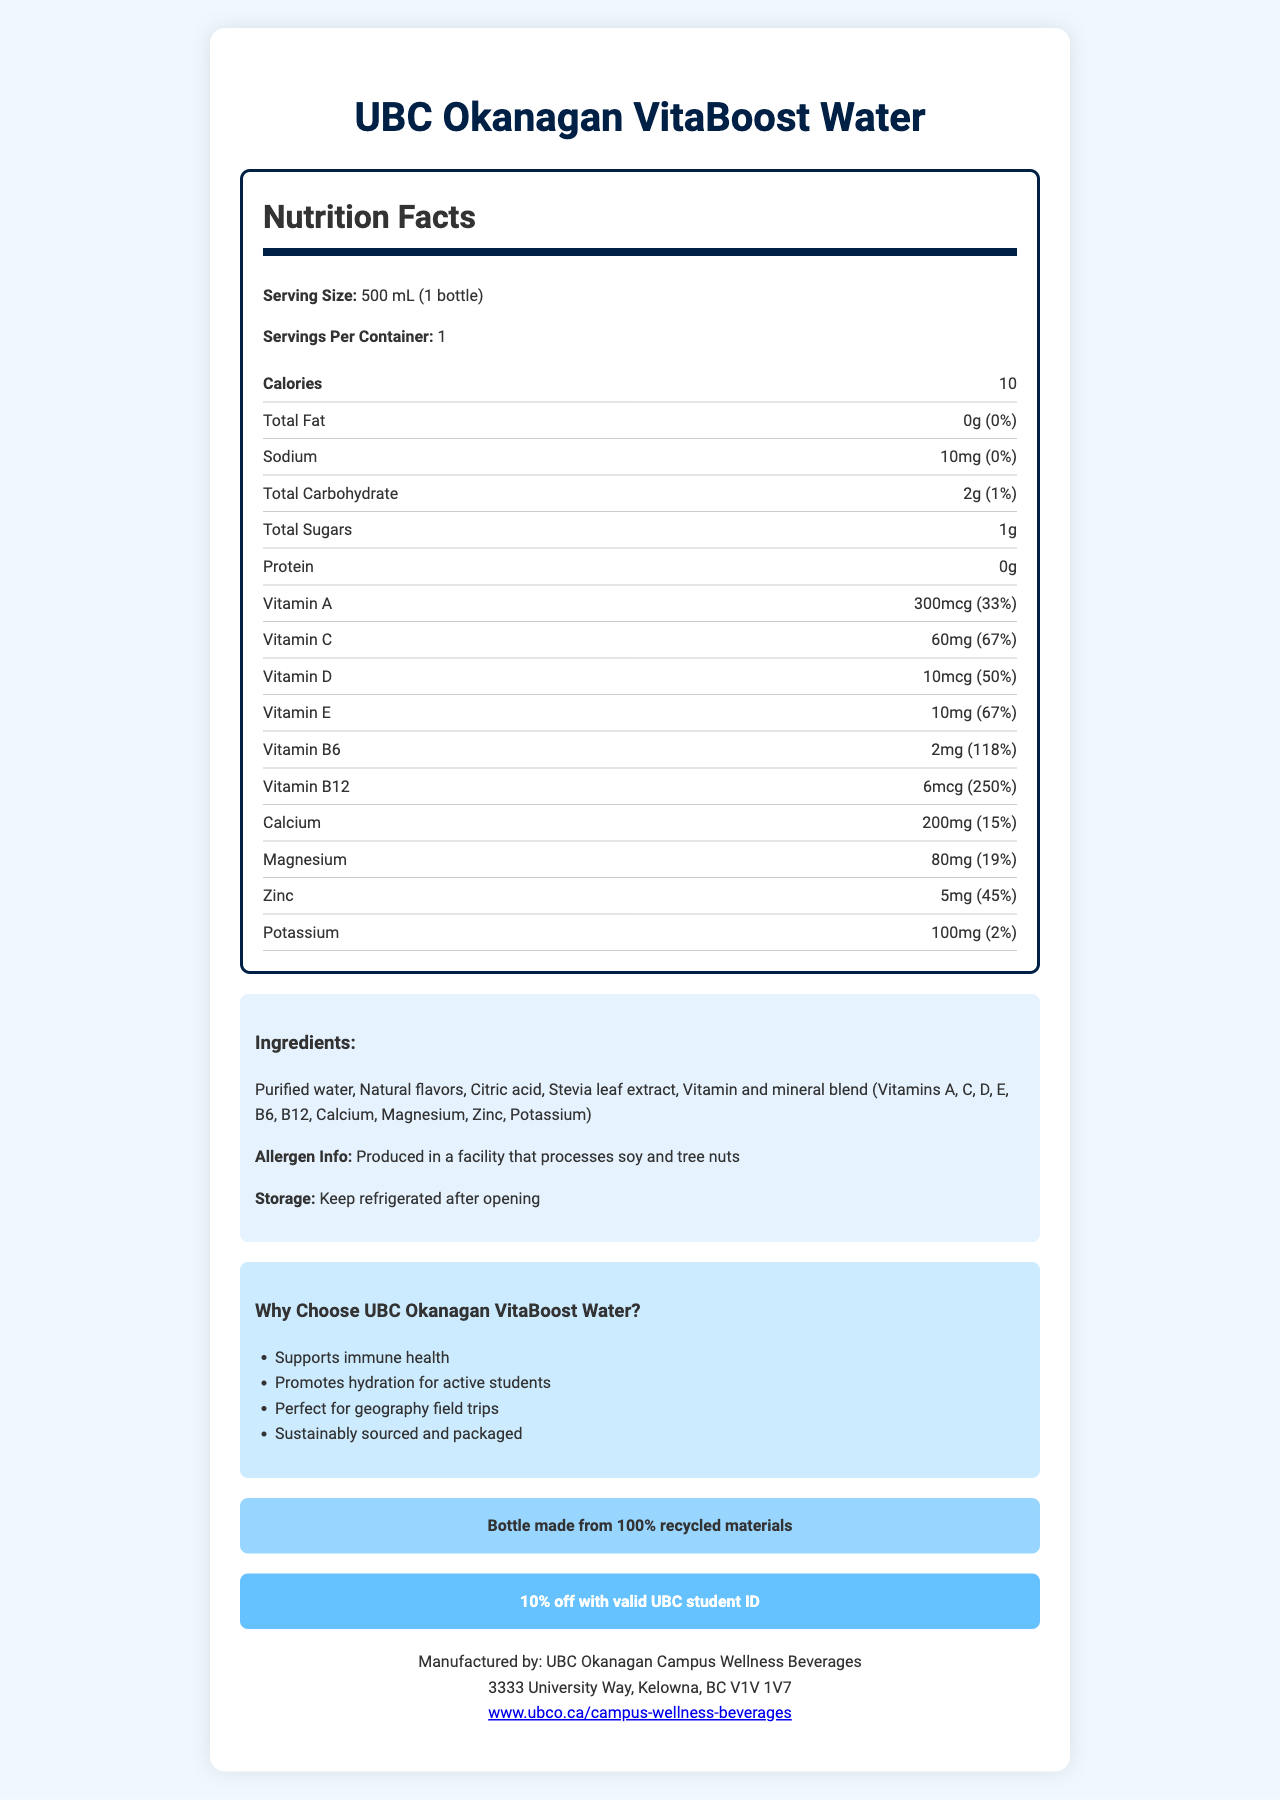what is the serving size of UBC Okanagan VitaBoost Water? The serving size is mentioned at the beginning of the Nutrition Facts section.
Answer: 500 mL (1 bottle) how many calories are in one serving of UBC Okanagan VitaBoost Water? The calorie count is prominently displayed in the Nutrition Facts section.
Answer: 10 calories what percentage of the daily value of Vitamin C does one serving provide? The daily value percentage for Vitamin C is listed in the nutrition information for Vitamin C.
Answer: 67% how many grams of total sugars are in one serving of UBC Okanagan VitaBoost Water? The amount of total sugars is listed under the "Total Sugars" heading in the Nutrition Facts section.
Answer: 1g what are the key vitamins and minerals highlighted in the UBC Okanagan VitaBoost Water's ingredient list? The vitamin and mineral blend in the ingredients list includes these nutrients.
Answer: Vitamins A, C, D, E, B6, B12, Calcium, Magnesium, Zinc, Potassium which of the following is a marketing claim made about UBC Okanagan VitaBoost Water? A. Enhances focus B. Supports immune health C. Improves digestion D. Increases strength The marketing claim "Supports immune health" is listed under "Why Choose UBC Okanagan VitaBoost Water?"
Answer: B. Supports immune health what is the daily value percentage of Vitamin B12 in one serving? A. 100% B. 150% C. 200% D. 250% The daily value percentage for Vitamin B12 is listed as 250% in the nutrition information.
Answer: D. 250% is UBC Okanagan VitaBoost Water suitable for those with soy allergies? The allergen info states that it is produced in a facility that processes soy and tree nuts.
Answer: No describe the eco-friendly aspect of the UBC Okanagan VitaBoost Water packaging. The eco-friendly info mentions that the bottle is made from 100% recycled materials.
Answer: Bottle made from 100% recycled materials what is the manufacturer's address for UBC Okanagan VitaBoost Water? The manufacturer's address is listed at the bottom of the document along with the manufacturing information.
Answer: 3333 University Way, Kelowna, BC V1V 1V7 what is the total carbohydrate content in UBC Okanagan VitaBoost Water? The total carbohydrate content is listed in the Nutrition Facts section.
Answer: 2g what is the UBC student discount for purchasing UBC Okanagan VitaBoost Water? The student discount is mentioned in a highlighted section towards the bottom of the document.
Answer: 10% off with valid UBC student ID what storage instructions are provided for UBC Okanagan VitaBoost Water? The storage instructions are stated in the ingredients section of the document.
Answer: Keep refrigerated after opening does UBC Okanagan VitaBoost Water contain any protein? The protein content is listed as 0g in the Nutrition Facts section.
Answer: No summarize the key intention of the UBC Okanagan VitaBoost Water document. The document is designed to inform potential consumers about the benefits, contents, and discounts associated with UBC Okanagan VitaBoost Water, emphasizing its suitability for health-conscious students.
Answer: The document provides detailed nutrition information, ingredients, marketing claims, and eco-friendly aspects of UBC Okanagan VitaBoost Water, a vitamin-fortified bottled water. It highlights the product's nutrient content, such as vitamins A, C, D, E, B6, and B12, calcium, magnesium, and zinc. The document also includes allergen info, storage instructions, and a student discount offer. what is the recommended daily intake value for Sodium in one serving? A. 0% B. 1% C. 5% D. 10% The daily value percentage for Sodium is listed as 0% in the Nutrition Facts section.
Answer: A. 0% which ingredient in UBC Okanagan VitaBoost Water might be used as a natural sweetener? Stevia leaf extract is a natural sweetener listed in the ingredients.
Answer: Stevia leaf extract what is the product name of the vitamin-fortified bottled water sold at UBC Okanagan campus convenience stores? The product name is mentioned at the very top of the document.
Answer: UBC Okanagan VitaBoost Water what marketing claim is associated with geography field trips? This specific marketing claim is listed under "Why Choose UBC Okanagan VitaBoost Water?"
Answer: Perfect for geography field trips how are the marketing claims presented in the document? The marketing claims are organized as a bulleted list within a highlighted section of the document.
Answer: They are listed in a bullet-point format under "Why Choose UBC Okanagan VitaBoost Water?" where can you find more information about UBC Okanagan Campus Wellness Beverages? The website for more information is listed at the bottom of the document.
Answer: www.ubco.ca/campus-wellness-beverages how much fat is in one serving of UBC Okanagan VitaBoost Water? The total fat content is listed as 0g in the Nutrition Facts section.
Answer: 0g where is UBC Okanagan VitaBoost Water produced? This information is mentioned in the allergen info section.
Answer: Produced in a facility that processes soy and tree nuts how many grams of protein are in one serving of UBC Okanagan VitaBoost Water? This information is found in the Nutrition Facts section where protein content is listed.
Answer: 0g what is the daily value percentage for magnesium in one serving? The daily value percentage for magnesium is provided in the Nutrition Facts section.
Answer: 19% when should the UBC Okanagan VitaBoost Water be refrigerated? The storage instructions state that the product should be kept refrigerated after opening.
Answer: After opening which essential mineral is present in the lowest daily value percentage in the UBC Okanagan VitaBoost Water? A. Calcium B. Potassium C. Sodium D. Zinc Sodium has the lowest daily value percentage (0%) among the listed minerals.
Answer: C. Sodium what type of extract is used as a flavoring ingredient in UBC Okanagan VitaBoost Water? The ingredients list includes Stevia leaf extract as a flavoring ingredient.
Answer: Stevia leaf extract can the daily value percentages for Iron be found in the document? The document does not provide any information regarding Iron content or its daily value percentage.
Answer: Cannot be determined is the bottle of UBC Okanagan VitaBoost Water made from newly sourced materials? The eco-friendly info specifies that the bottle is made from 100% recycled materials.
Answer: No 